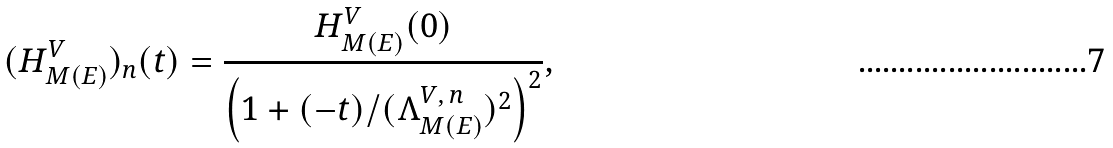<formula> <loc_0><loc_0><loc_500><loc_500>( H _ { M ( E ) } ^ { V } ) _ { n } ( t ) = \frac { H _ { M ( E ) } ^ { V } ( 0 ) } { \left ( 1 + ( - t ) / ( \Lambda _ { M ( E ) } ^ { V , \, n } ) ^ { 2 } \right ) ^ { 2 } } ,</formula> 